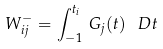Convert formula to latex. <formula><loc_0><loc_0><loc_500><loc_500>W ^ { - } _ { i j } = \int _ { - 1 } ^ { t _ { i } } \, G _ { j } ( t ) \, \ D t</formula> 